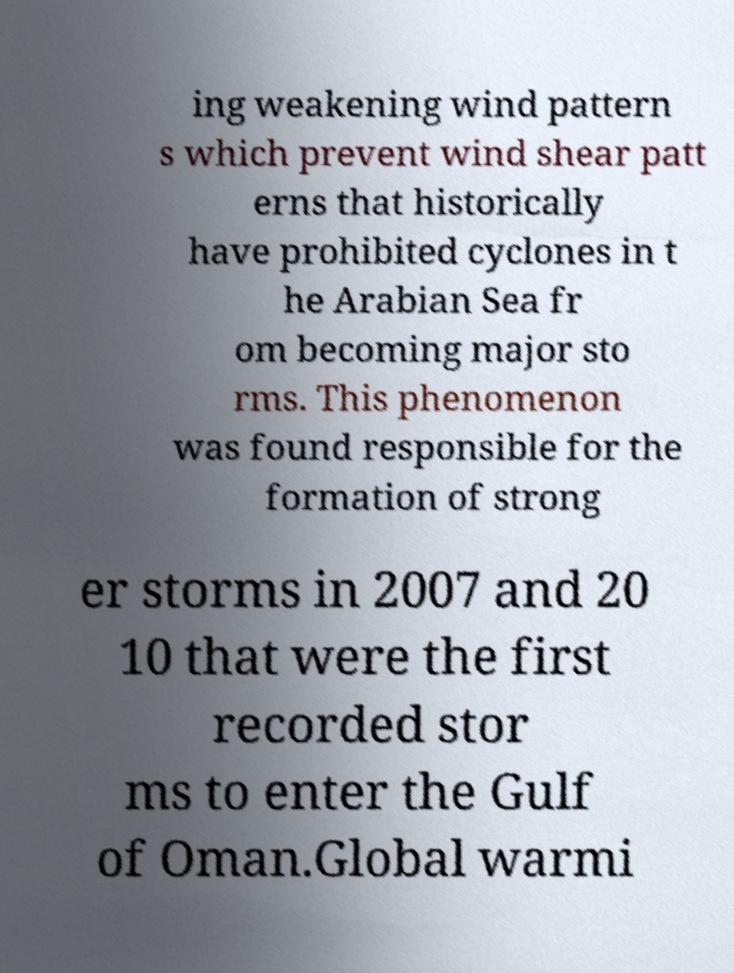Could you assist in decoding the text presented in this image and type it out clearly? ing weakening wind pattern s which prevent wind shear patt erns that historically have prohibited cyclones in t he Arabian Sea fr om becoming major sto rms. This phenomenon was found responsible for the formation of strong er storms in 2007 and 20 10 that were the first recorded stor ms to enter the Gulf of Oman.Global warmi 